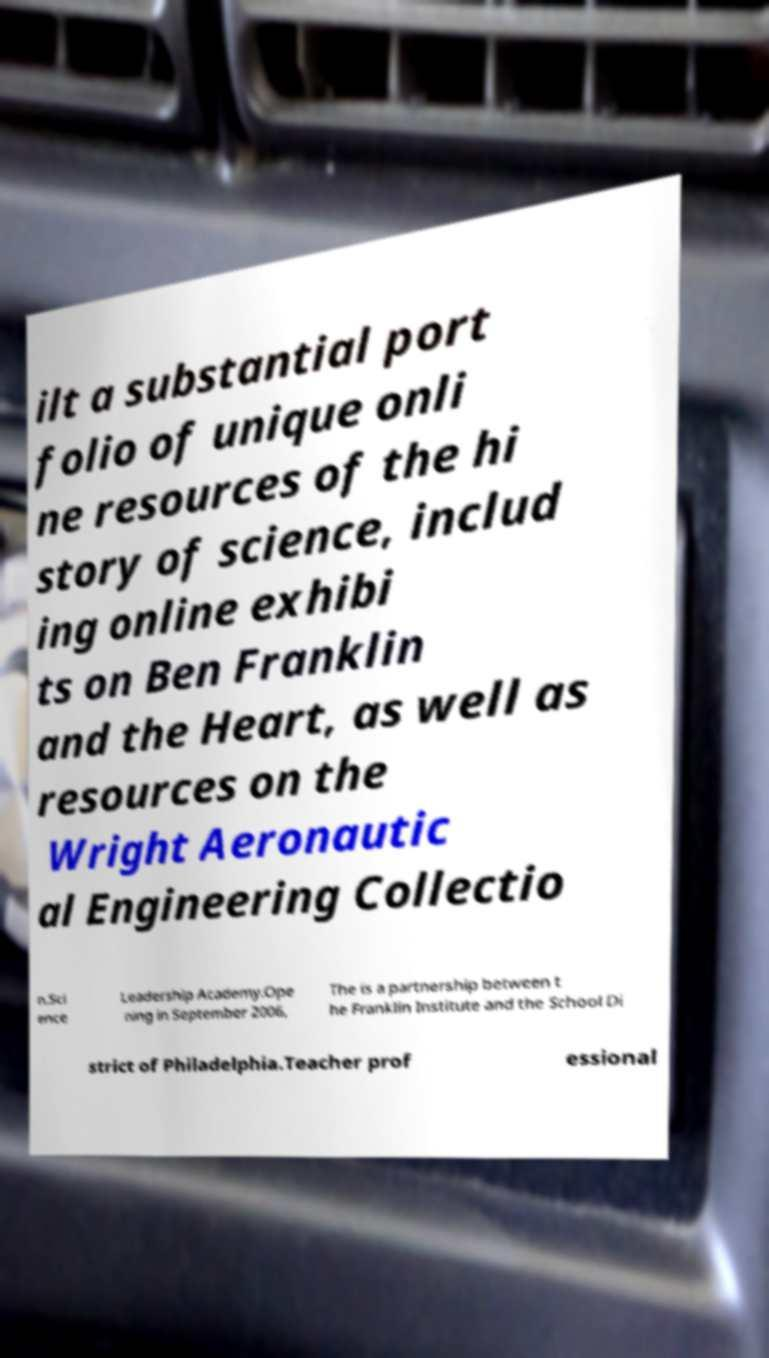Could you assist in decoding the text presented in this image and type it out clearly? ilt a substantial port folio of unique onli ne resources of the hi story of science, includ ing online exhibi ts on Ben Franklin and the Heart, as well as resources on the Wright Aeronautic al Engineering Collectio n.Sci ence Leadership Academy.Ope ning in September 2006, The is a partnership between t he Franklin Institute and the School Di strict of Philadelphia.Teacher prof essional 